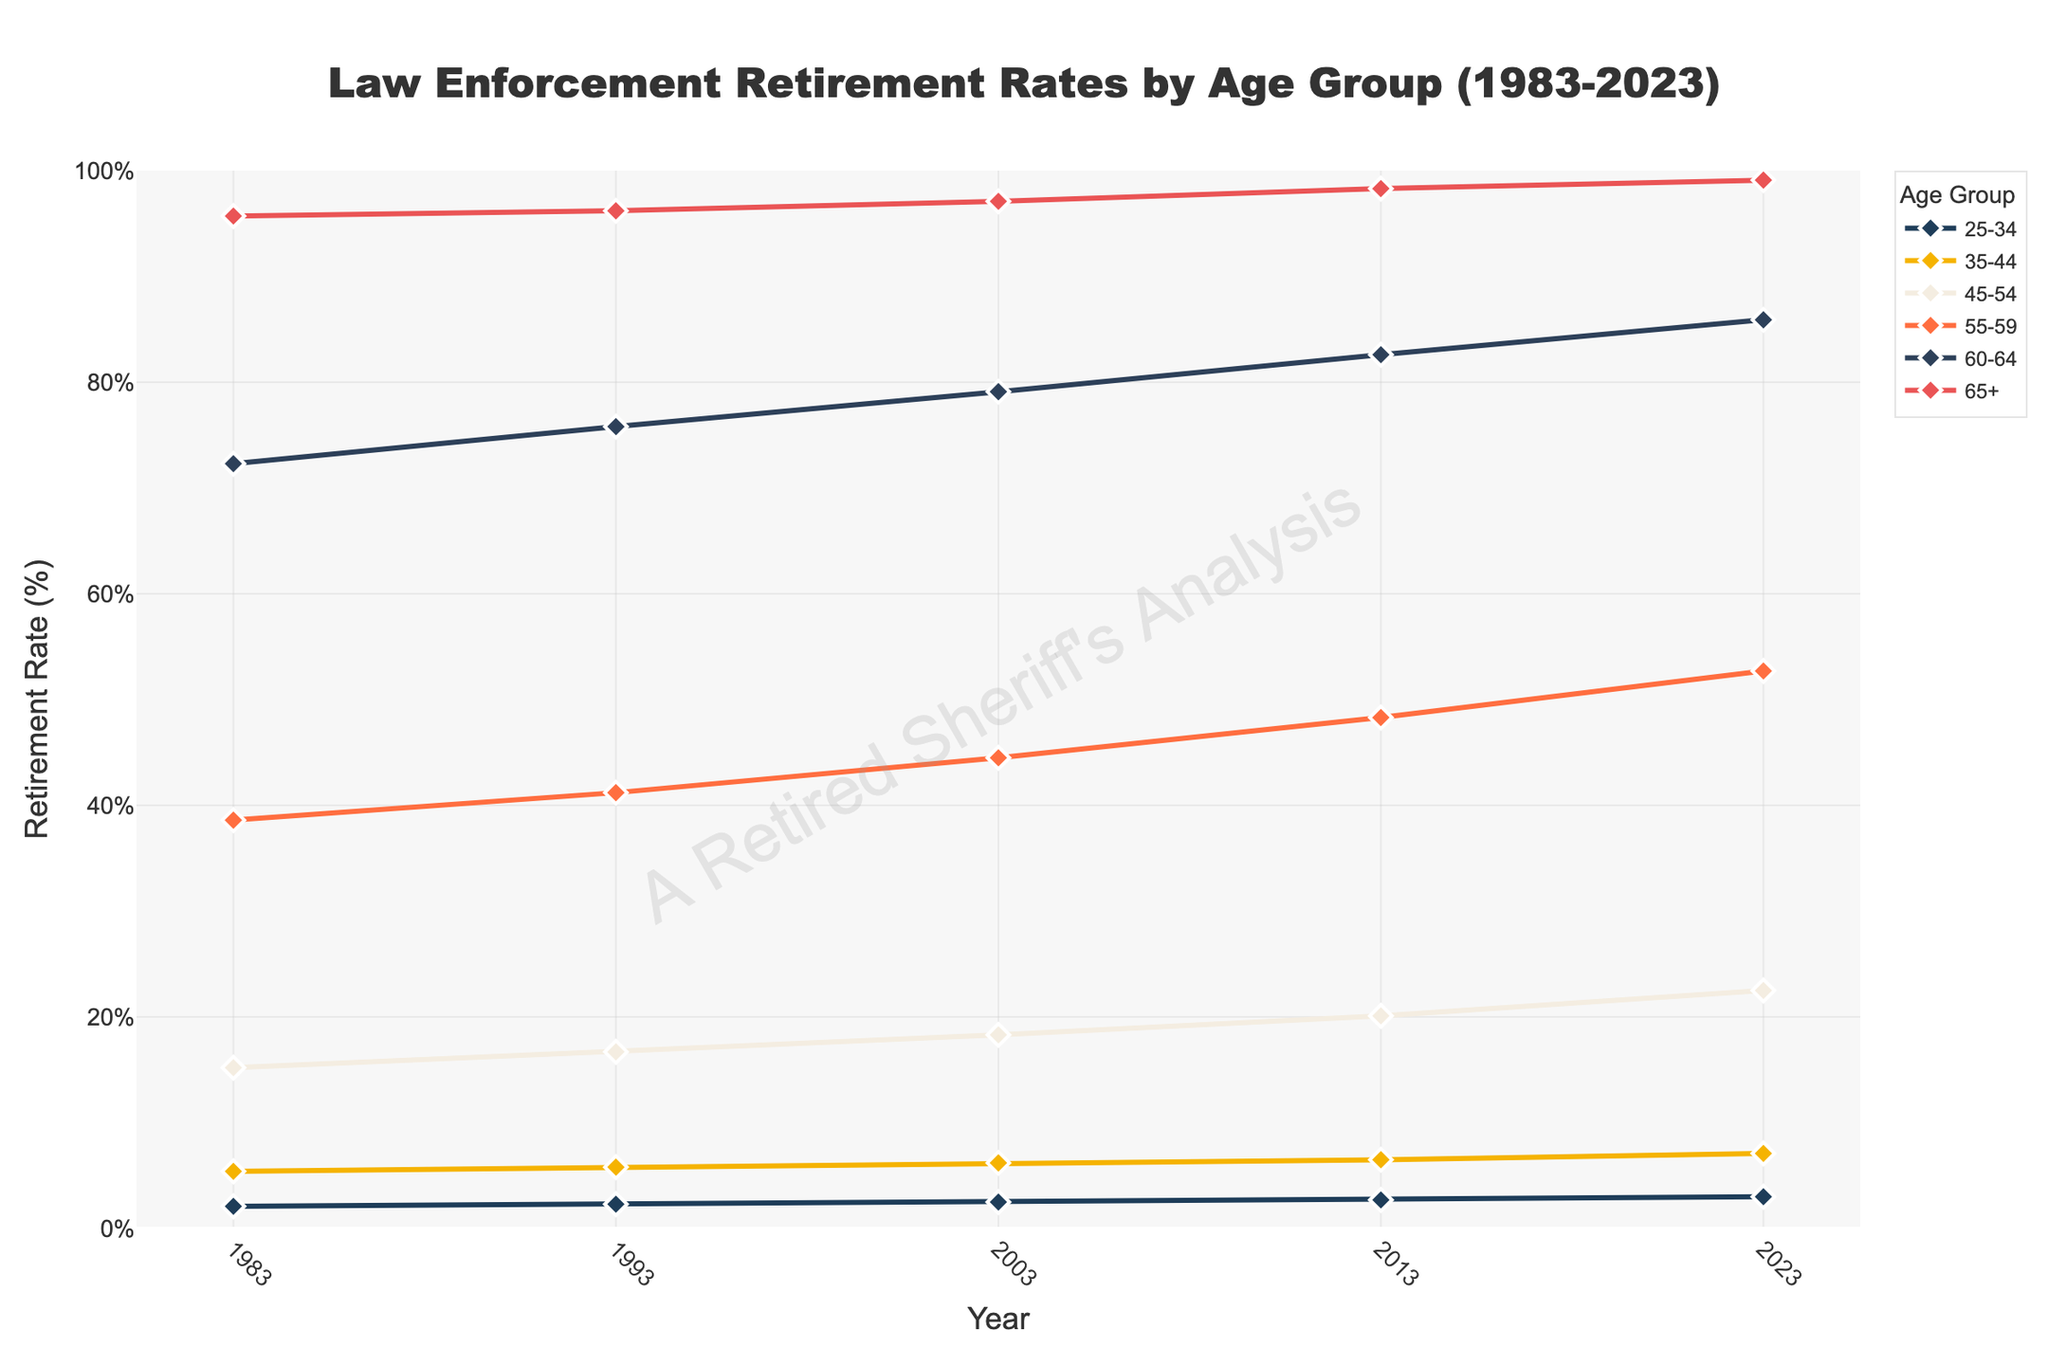What is the retirement rate for the 55-59 age group in 2023? Locate the '55-59' age group and the year '2023'. The corresponding value is the retirement rate for that age group and year.
Answer: 52.7% What age group has the highest retirement rate in 2023? Compare the retirement rates of all age groups for the year 2023. The '65+' age group has the highest retirement rate.
Answer: 65+ Which age group saw the largest increase in retirement rate from 1983 to 2023? Calculate the difference between the retirement rates in 2023 and 1983 for each age group, and identify the largest increase. The '25-34' age group increased by (3.0% - 2.1%) = 0.9%, the '35-44' age group increased by (7.1% - 5.4%) = 1.7%, the '45-54' age group increased by (22.5% - 15.2%) = 7.3%, the '55-59' age group increased by (52.7% - 38.6%) = 14.1%, the '60-64' age group increased by (85.9% - 72.3%) = 13.6%, and the '65+' age group increased by (99.1% - 95.7%) = 3.4%.
Answer: 55-59 Which age group's retirement rate exceeded 50% first according to the chart? Look for the first instance where the retirement rate for any age group exceeds 50%. The '60-64' age group exceeded 50% in 1983 with 72.3%.
Answer: 60-64 How does the retirement rate for the 45-54 age group in 2003 compare to its rate in 2013? Identify the retirement rates for the '45-54' age group in 2003 and 2013. Compare 18.3% in 2003 to 20.1% in 2013. The rate increased by (20.1% - 18.3%) = 1.8%.
Answer: Increased by 1.8% What pattern do you observe in the retirement rates for all age groups between 1983 and 2023? Analyze the trends for all age groups over the years. All age groups show a steadily increasing trend in retirement rates from 1983 to 2023.
Answer: Increasing trend What was the retirement rate of the '25-34' age group in 1983 compared to the '35-44' age group in the same year? Check the retirement rates of the '25-34' and '35-44' age groups in 1983. The '25-34' age group had a retirement rate of 2.1%, while the '35-44' age group had a retirement rate of 5.4%.
Answer: 2.1% vs 5.4% Did any age group have a retirement rate of 100% in any year? Review the retirement rates of all age groups for all years to see if any reach 100%. No age group reached 100% retirement rate in any year.
Answer: No Which age group was the first to reach a retirement rate of over 80%, and in what year did this happen? Identify the first instance when an age group's retirement rate crosses 80%. The '60-64' age group reached 82.6% in 2013.
Answer: 60-64 in 2013 By how much did the retirement rate of the '45-54' age group increase from 1993 to 2023? Calculate the increase by subtracting the retirement rate of the '45-54' age group in 1993 (16.7%) from the rate in 2023 (22.5%). (22.5% - 16.7%) = 5.8%.
Answer: 5.8% 